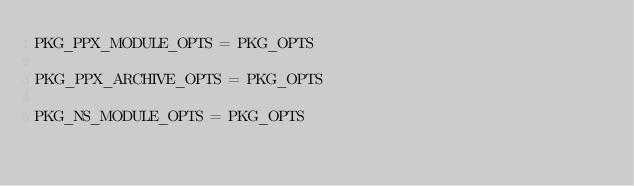Convert code to text. <code><loc_0><loc_0><loc_500><loc_500><_Python_>PKG_PPX_MODULE_OPTS = PKG_OPTS

PKG_PPX_ARCHIVE_OPTS = PKG_OPTS

PKG_NS_MODULE_OPTS = PKG_OPTS
</code> 